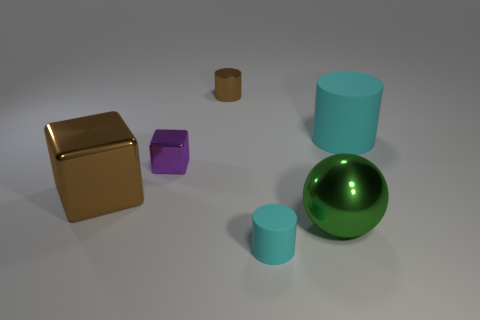Subtract all red blocks. How many cyan cylinders are left? 2 Subtract all cyan rubber cylinders. How many cylinders are left? 1 Add 2 small brown objects. How many objects exist? 8 Subtract all cubes. How many objects are left? 4 Subtract 1 brown blocks. How many objects are left? 5 Subtract all brown metal blocks. Subtract all green objects. How many objects are left? 4 Add 2 brown objects. How many brown objects are left? 4 Add 6 cyan rubber things. How many cyan rubber things exist? 8 